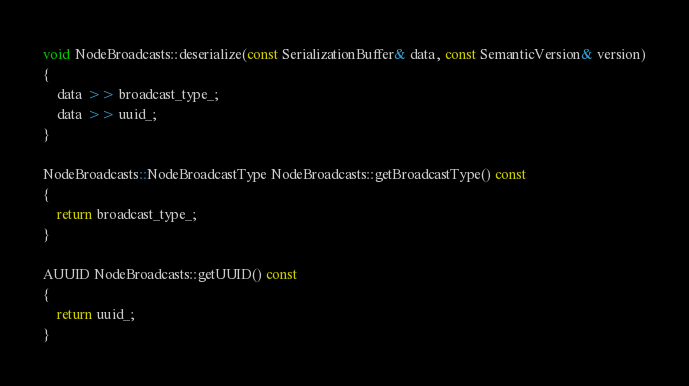<code> <loc_0><loc_0><loc_500><loc_500><_C++_>
void NodeBroadcasts::deserialize(const SerializationBuffer& data, const SemanticVersion& version)
{
    data >> broadcast_type_;
    data >> uuid_;
}

NodeBroadcasts::NodeBroadcastType NodeBroadcasts::getBroadcastType() const
{
    return broadcast_type_;
}

AUUID NodeBroadcasts::getUUID() const
{
    return uuid_;
}
</code> 